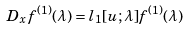Convert formula to latex. <formula><loc_0><loc_0><loc_500><loc_500>D _ { x } f ^ { ( 1 ) } ( \lambda ) = l _ { 1 } [ u ; \lambda ] f ^ { ( 1 ) } ( \lambda )</formula> 